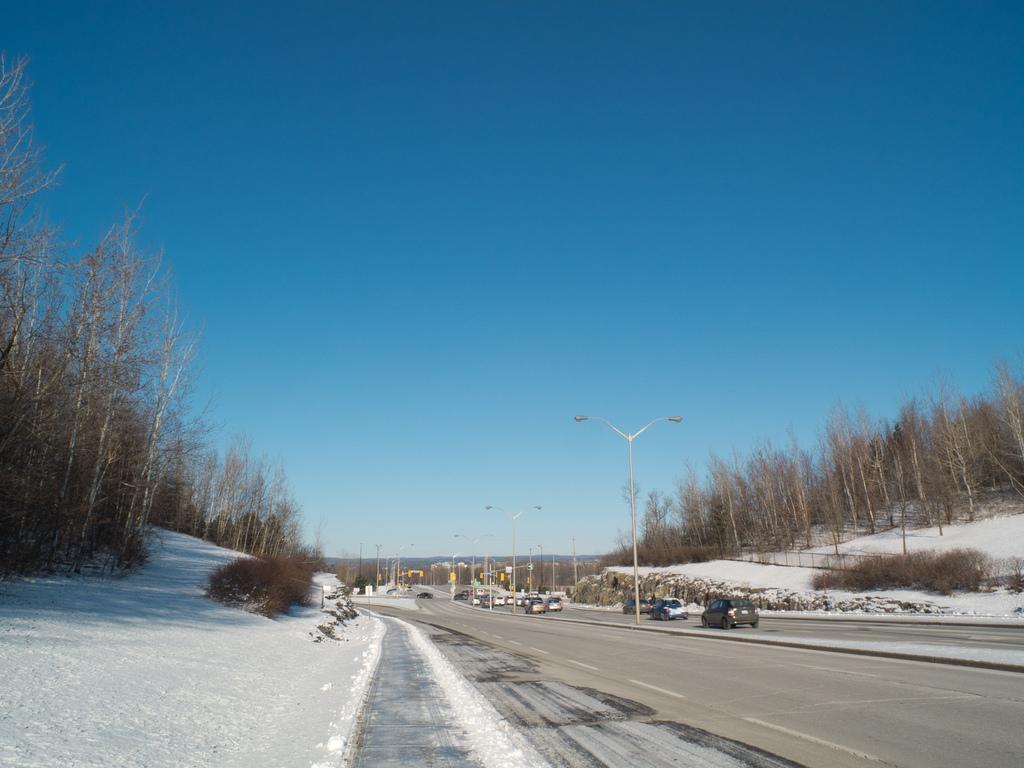How would you summarize this image in a sentence or two? In this picture we can see many cars on the road. On the divided we can see many street lights. On the right and left side we can see many trees. At the bottom we can see the snow. At the top there is a sky. 